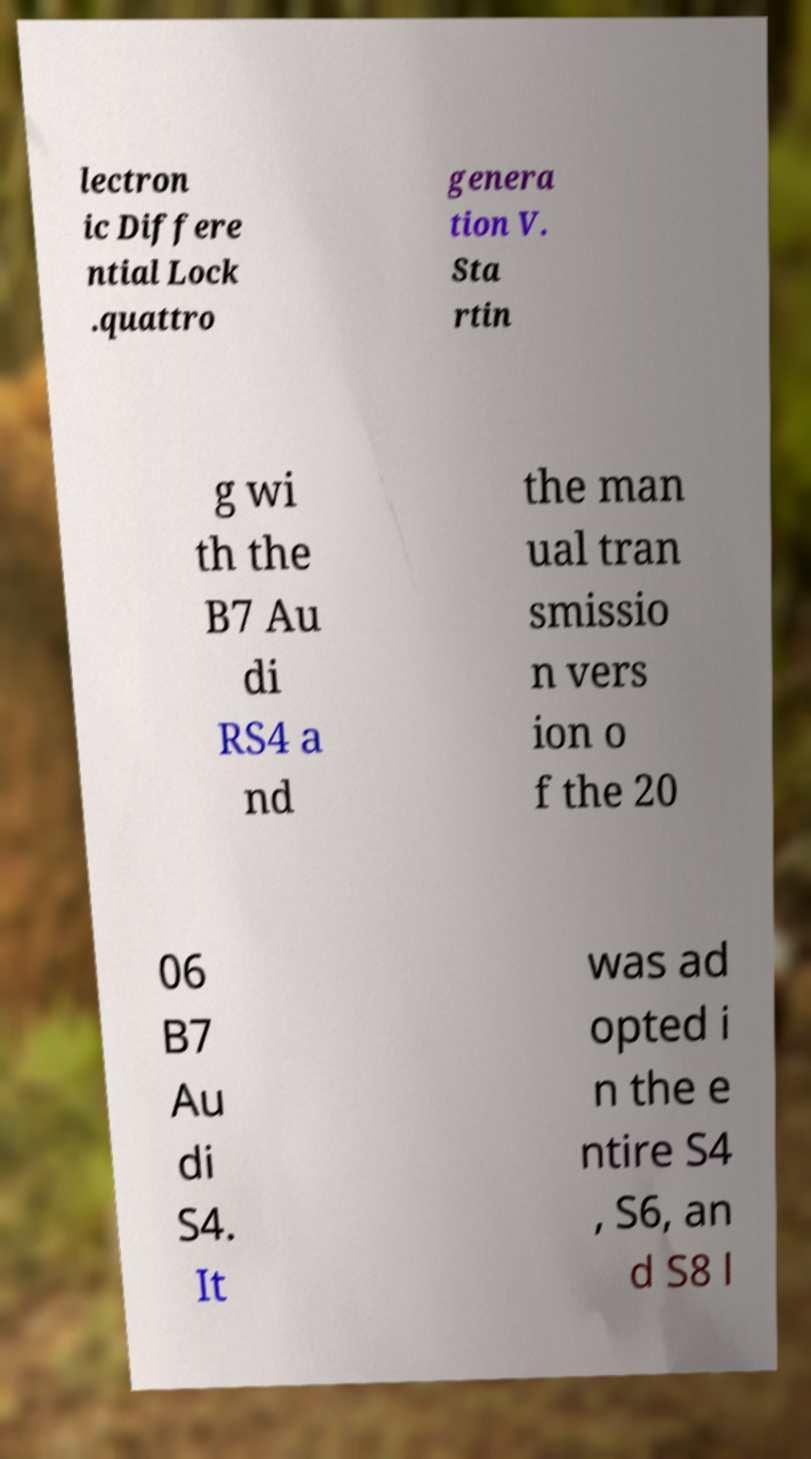Can you read and provide the text displayed in the image?This photo seems to have some interesting text. Can you extract and type it out for me? lectron ic Differe ntial Lock .quattro genera tion V. Sta rtin g wi th the B7 Au di RS4 a nd the man ual tran smissio n vers ion o f the 20 06 B7 Au di S4. It was ad opted i n the e ntire S4 , S6, an d S8 l 